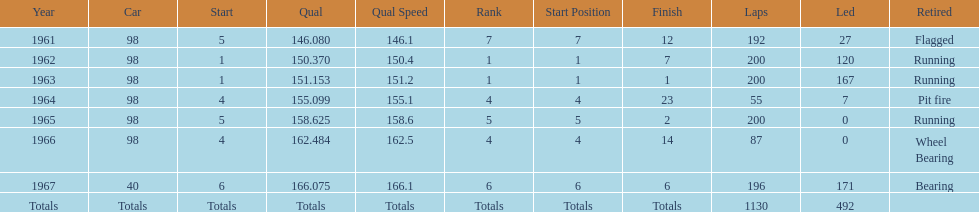What car achieved the highest qual? 40. 